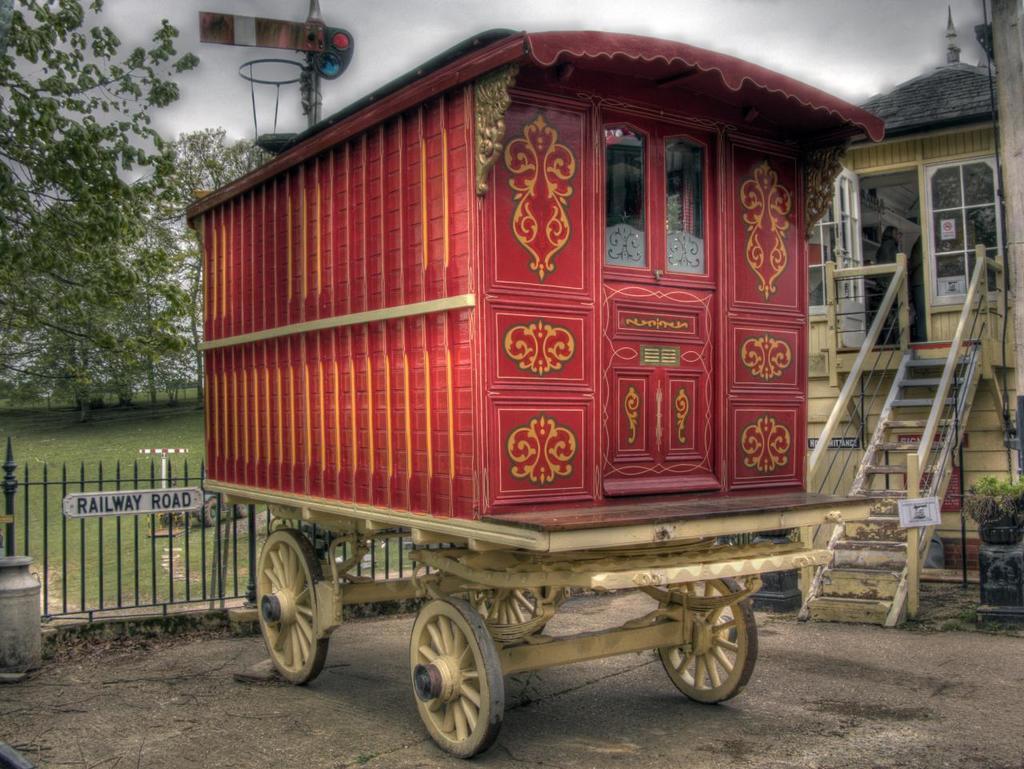Describe this image in one or two sentences. In this image there is a trolley in the middle. On the right side there is a small house. In front of it there are steps. In the background there is a ground. On the ground there is a tree. There is a fence behind the trolley. At the top there is a pole to which there is a board. On the trolley there is a small house like structure. 